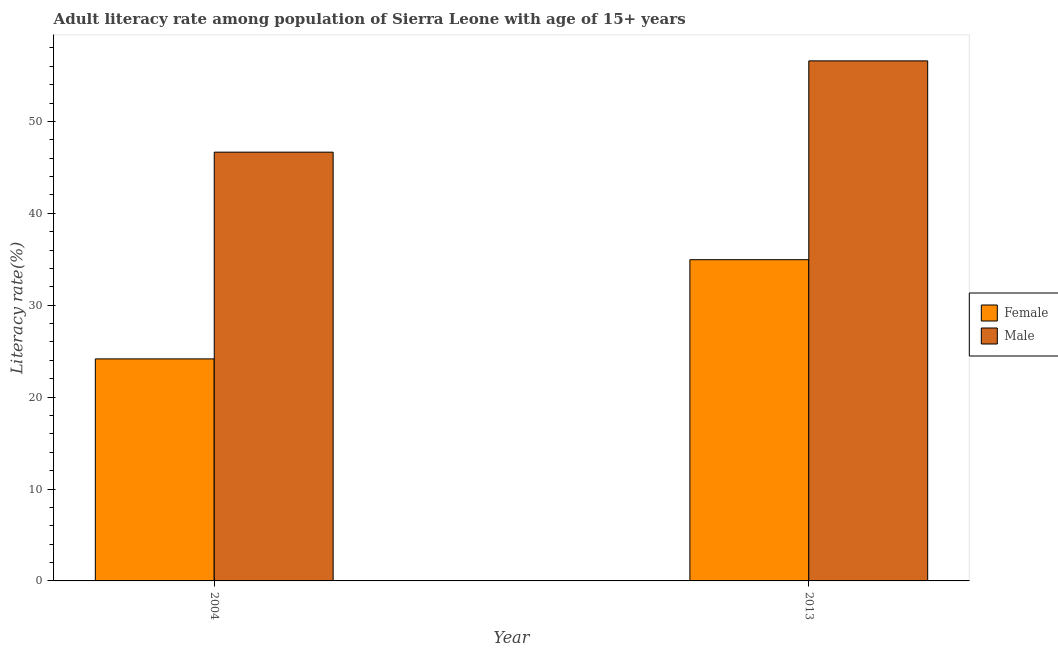How many groups of bars are there?
Provide a short and direct response. 2. Are the number of bars per tick equal to the number of legend labels?
Your answer should be very brief. Yes. Are the number of bars on each tick of the X-axis equal?
Keep it short and to the point. Yes. How many bars are there on the 1st tick from the left?
Your answer should be very brief. 2. In how many cases, is the number of bars for a given year not equal to the number of legend labels?
Your response must be concise. 0. What is the female adult literacy rate in 2004?
Keep it short and to the point. 24.16. Across all years, what is the maximum female adult literacy rate?
Give a very brief answer. 34.95. Across all years, what is the minimum female adult literacy rate?
Make the answer very short. 24.16. In which year was the female adult literacy rate maximum?
Offer a terse response. 2013. In which year was the male adult literacy rate minimum?
Your response must be concise. 2004. What is the total male adult literacy rate in the graph?
Keep it short and to the point. 103.24. What is the difference between the male adult literacy rate in 2004 and that in 2013?
Your answer should be compact. -9.93. What is the difference between the male adult literacy rate in 2013 and the female adult literacy rate in 2004?
Ensure brevity in your answer.  9.93. What is the average female adult literacy rate per year?
Your answer should be compact. 29.56. In the year 2013, what is the difference between the male adult literacy rate and female adult literacy rate?
Provide a short and direct response. 0. In how many years, is the female adult literacy rate greater than 54 %?
Offer a terse response. 0. What is the ratio of the male adult literacy rate in 2004 to that in 2013?
Give a very brief answer. 0.82. Is the female adult literacy rate in 2004 less than that in 2013?
Provide a succinct answer. Yes. What does the 1st bar from the right in 2013 represents?
Offer a terse response. Male. How many bars are there?
Make the answer very short. 4. Are all the bars in the graph horizontal?
Keep it short and to the point. No. Does the graph contain grids?
Offer a terse response. No. What is the title of the graph?
Offer a very short reply. Adult literacy rate among population of Sierra Leone with age of 15+ years. Does "Gasoline" appear as one of the legend labels in the graph?
Provide a short and direct response. No. What is the label or title of the X-axis?
Keep it short and to the point. Year. What is the label or title of the Y-axis?
Your answer should be very brief. Literacy rate(%). What is the Literacy rate(%) of Female in 2004?
Keep it short and to the point. 24.16. What is the Literacy rate(%) in Male in 2004?
Provide a short and direct response. 46.65. What is the Literacy rate(%) of Female in 2013?
Your answer should be very brief. 34.95. What is the Literacy rate(%) in Male in 2013?
Your answer should be compact. 56.59. Across all years, what is the maximum Literacy rate(%) of Female?
Offer a terse response. 34.95. Across all years, what is the maximum Literacy rate(%) of Male?
Keep it short and to the point. 56.59. Across all years, what is the minimum Literacy rate(%) of Female?
Your answer should be compact. 24.16. Across all years, what is the minimum Literacy rate(%) of Male?
Your response must be concise. 46.65. What is the total Literacy rate(%) in Female in the graph?
Provide a succinct answer. 59.11. What is the total Literacy rate(%) in Male in the graph?
Your answer should be compact. 103.24. What is the difference between the Literacy rate(%) in Female in 2004 and that in 2013?
Provide a succinct answer. -10.79. What is the difference between the Literacy rate(%) of Male in 2004 and that in 2013?
Give a very brief answer. -9.93. What is the difference between the Literacy rate(%) of Female in 2004 and the Literacy rate(%) of Male in 2013?
Offer a very short reply. -32.43. What is the average Literacy rate(%) in Female per year?
Give a very brief answer. 29.56. What is the average Literacy rate(%) in Male per year?
Your response must be concise. 51.62. In the year 2004, what is the difference between the Literacy rate(%) of Female and Literacy rate(%) of Male?
Your answer should be compact. -22.5. In the year 2013, what is the difference between the Literacy rate(%) in Female and Literacy rate(%) in Male?
Offer a very short reply. -21.63. What is the ratio of the Literacy rate(%) in Female in 2004 to that in 2013?
Provide a short and direct response. 0.69. What is the ratio of the Literacy rate(%) of Male in 2004 to that in 2013?
Ensure brevity in your answer.  0.82. What is the difference between the highest and the second highest Literacy rate(%) of Female?
Make the answer very short. 10.79. What is the difference between the highest and the second highest Literacy rate(%) in Male?
Provide a short and direct response. 9.93. What is the difference between the highest and the lowest Literacy rate(%) of Female?
Ensure brevity in your answer.  10.79. What is the difference between the highest and the lowest Literacy rate(%) of Male?
Make the answer very short. 9.93. 